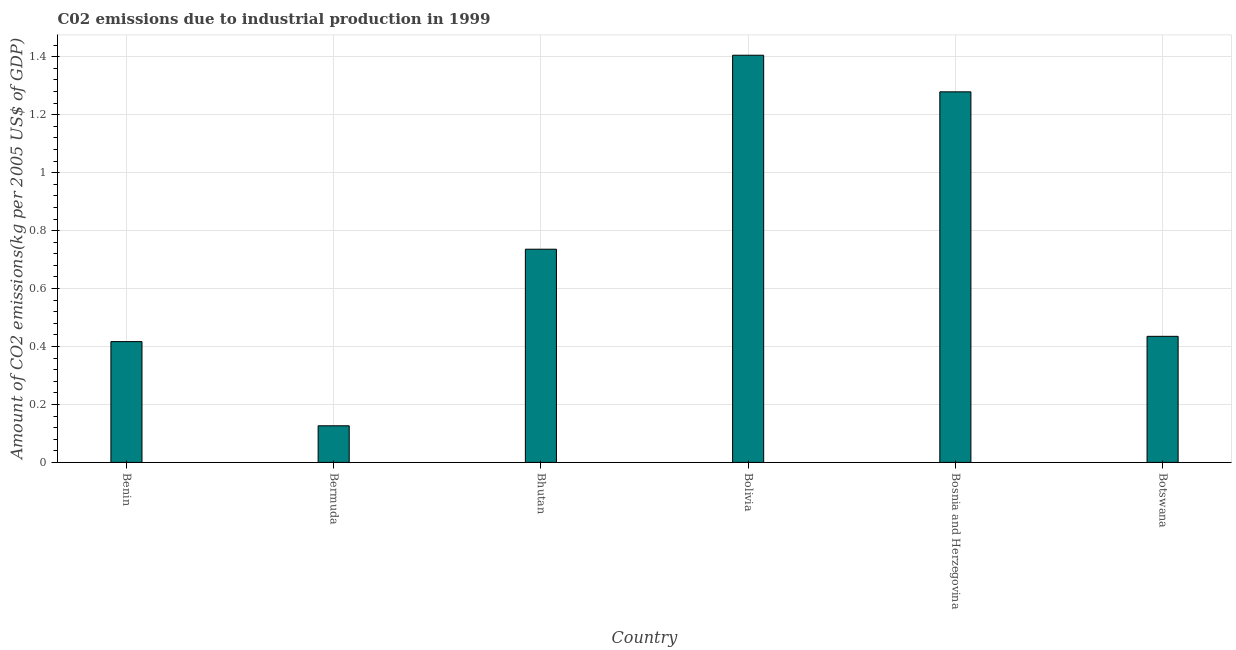Does the graph contain grids?
Keep it short and to the point. Yes. What is the title of the graph?
Offer a terse response. C02 emissions due to industrial production in 1999. What is the label or title of the X-axis?
Your answer should be compact. Country. What is the label or title of the Y-axis?
Your answer should be compact. Amount of CO2 emissions(kg per 2005 US$ of GDP). What is the amount of co2 emissions in Bhutan?
Your response must be concise. 0.74. Across all countries, what is the maximum amount of co2 emissions?
Keep it short and to the point. 1.41. Across all countries, what is the minimum amount of co2 emissions?
Your answer should be very brief. 0.13. In which country was the amount of co2 emissions maximum?
Offer a terse response. Bolivia. In which country was the amount of co2 emissions minimum?
Give a very brief answer. Bermuda. What is the sum of the amount of co2 emissions?
Ensure brevity in your answer.  4.4. What is the difference between the amount of co2 emissions in Bosnia and Herzegovina and Botswana?
Give a very brief answer. 0.84. What is the average amount of co2 emissions per country?
Provide a short and direct response. 0.73. What is the median amount of co2 emissions?
Keep it short and to the point. 0.59. What is the ratio of the amount of co2 emissions in Benin to that in Bermuda?
Make the answer very short. 3.3. Is the amount of co2 emissions in Bhutan less than that in Botswana?
Your answer should be very brief. No. Is the difference between the amount of co2 emissions in Bermuda and Bolivia greater than the difference between any two countries?
Ensure brevity in your answer.  Yes. What is the difference between the highest and the second highest amount of co2 emissions?
Offer a very short reply. 0.13. Is the sum of the amount of co2 emissions in Bosnia and Herzegovina and Botswana greater than the maximum amount of co2 emissions across all countries?
Offer a terse response. Yes. What is the difference between the highest and the lowest amount of co2 emissions?
Your answer should be very brief. 1.28. In how many countries, is the amount of co2 emissions greater than the average amount of co2 emissions taken over all countries?
Your response must be concise. 3. How many bars are there?
Your answer should be compact. 6. What is the Amount of CO2 emissions(kg per 2005 US$ of GDP) of Benin?
Offer a very short reply. 0.42. What is the Amount of CO2 emissions(kg per 2005 US$ of GDP) in Bermuda?
Make the answer very short. 0.13. What is the Amount of CO2 emissions(kg per 2005 US$ of GDP) in Bhutan?
Your answer should be very brief. 0.74. What is the Amount of CO2 emissions(kg per 2005 US$ of GDP) in Bolivia?
Give a very brief answer. 1.41. What is the Amount of CO2 emissions(kg per 2005 US$ of GDP) in Bosnia and Herzegovina?
Keep it short and to the point. 1.28. What is the Amount of CO2 emissions(kg per 2005 US$ of GDP) in Botswana?
Make the answer very short. 0.44. What is the difference between the Amount of CO2 emissions(kg per 2005 US$ of GDP) in Benin and Bermuda?
Your response must be concise. 0.29. What is the difference between the Amount of CO2 emissions(kg per 2005 US$ of GDP) in Benin and Bhutan?
Provide a short and direct response. -0.32. What is the difference between the Amount of CO2 emissions(kg per 2005 US$ of GDP) in Benin and Bolivia?
Give a very brief answer. -0.99. What is the difference between the Amount of CO2 emissions(kg per 2005 US$ of GDP) in Benin and Bosnia and Herzegovina?
Offer a very short reply. -0.86. What is the difference between the Amount of CO2 emissions(kg per 2005 US$ of GDP) in Benin and Botswana?
Give a very brief answer. -0.02. What is the difference between the Amount of CO2 emissions(kg per 2005 US$ of GDP) in Bermuda and Bhutan?
Make the answer very short. -0.61. What is the difference between the Amount of CO2 emissions(kg per 2005 US$ of GDP) in Bermuda and Bolivia?
Ensure brevity in your answer.  -1.28. What is the difference between the Amount of CO2 emissions(kg per 2005 US$ of GDP) in Bermuda and Bosnia and Herzegovina?
Offer a very short reply. -1.15. What is the difference between the Amount of CO2 emissions(kg per 2005 US$ of GDP) in Bermuda and Botswana?
Your answer should be compact. -0.31. What is the difference between the Amount of CO2 emissions(kg per 2005 US$ of GDP) in Bhutan and Bolivia?
Provide a succinct answer. -0.67. What is the difference between the Amount of CO2 emissions(kg per 2005 US$ of GDP) in Bhutan and Bosnia and Herzegovina?
Provide a short and direct response. -0.54. What is the difference between the Amount of CO2 emissions(kg per 2005 US$ of GDP) in Bhutan and Botswana?
Keep it short and to the point. 0.3. What is the difference between the Amount of CO2 emissions(kg per 2005 US$ of GDP) in Bolivia and Bosnia and Herzegovina?
Your response must be concise. 0.13. What is the difference between the Amount of CO2 emissions(kg per 2005 US$ of GDP) in Bolivia and Botswana?
Provide a succinct answer. 0.97. What is the difference between the Amount of CO2 emissions(kg per 2005 US$ of GDP) in Bosnia and Herzegovina and Botswana?
Keep it short and to the point. 0.84. What is the ratio of the Amount of CO2 emissions(kg per 2005 US$ of GDP) in Benin to that in Bermuda?
Give a very brief answer. 3.3. What is the ratio of the Amount of CO2 emissions(kg per 2005 US$ of GDP) in Benin to that in Bhutan?
Your response must be concise. 0.57. What is the ratio of the Amount of CO2 emissions(kg per 2005 US$ of GDP) in Benin to that in Bolivia?
Provide a succinct answer. 0.3. What is the ratio of the Amount of CO2 emissions(kg per 2005 US$ of GDP) in Benin to that in Bosnia and Herzegovina?
Provide a short and direct response. 0.33. What is the ratio of the Amount of CO2 emissions(kg per 2005 US$ of GDP) in Benin to that in Botswana?
Ensure brevity in your answer.  0.96. What is the ratio of the Amount of CO2 emissions(kg per 2005 US$ of GDP) in Bermuda to that in Bhutan?
Give a very brief answer. 0.17. What is the ratio of the Amount of CO2 emissions(kg per 2005 US$ of GDP) in Bermuda to that in Bolivia?
Give a very brief answer. 0.09. What is the ratio of the Amount of CO2 emissions(kg per 2005 US$ of GDP) in Bermuda to that in Bosnia and Herzegovina?
Give a very brief answer. 0.1. What is the ratio of the Amount of CO2 emissions(kg per 2005 US$ of GDP) in Bermuda to that in Botswana?
Ensure brevity in your answer.  0.29. What is the ratio of the Amount of CO2 emissions(kg per 2005 US$ of GDP) in Bhutan to that in Bolivia?
Ensure brevity in your answer.  0.52. What is the ratio of the Amount of CO2 emissions(kg per 2005 US$ of GDP) in Bhutan to that in Bosnia and Herzegovina?
Your response must be concise. 0.57. What is the ratio of the Amount of CO2 emissions(kg per 2005 US$ of GDP) in Bhutan to that in Botswana?
Provide a succinct answer. 1.69. What is the ratio of the Amount of CO2 emissions(kg per 2005 US$ of GDP) in Bolivia to that in Bosnia and Herzegovina?
Your answer should be very brief. 1.1. What is the ratio of the Amount of CO2 emissions(kg per 2005 US$ of GDP) in Bolivia to that in Botswana?
Your answer should be very brief. 3.23. What is the ratio of the Amount of CO2 emissions(kg per 2005 US$ of GDP) in Bosnia and Herzegovina to that in Botswana?
Offer a very short reply. 2.94. 